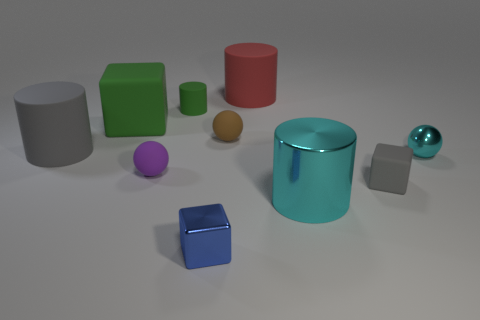What is the shape of the large thing that is the same color as the small shiny ball?
Offer a very short reply. Cylinder. What number of objects are either metallic balls or spheres left of the metallic cube?
Your answer should be compact. 2. Do the green object that is to the left of the purple object and the blue object have the same size?
Give a very brief answer. No. What material is the large cylinder that is in front of the purple rubber thing?
Offer a terse response. Metal. Is the number of big green matte things that are right of the tiny matte block the same as the number of gray rubber things on the left side of the tiny brown object?
Make the answer very short. No. What color is the tiny rubber object that is the same shape as the blue metallic thing?
Your answer should be compact. Gray. Is there any other thing of the same color as the large matte block?
Give a very brief answer. Yes. What number of matte objects are either tiny purple balls or small brown cylinders?
Your answer should be compact. 1. Is the big shiny object the same color as the metal sphere?
Your response must be concise. Yes. Are there more cylinders that are behind the big metallic thing than metal balls?
Your answer should be very brief. Yes. 